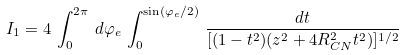<formula> <loc_0><loc_0><loc_500><loc_500>I _ { 1 } = 4 \, \int _ { 0 } ^ { 2 \pi } \, d \varphi _ { e } \, \int _ { 0 } ^ { \sin ( \varphi _ { e } / 2 ) } \, \frac { d t } { [ ( 1 - t ^ { 2 } ) ( z ^ { 2 } + 4 R _ { C N } ^ { 2 } t ^ { 2 } ) ] ^ { 1 / 2 } }</formula> 